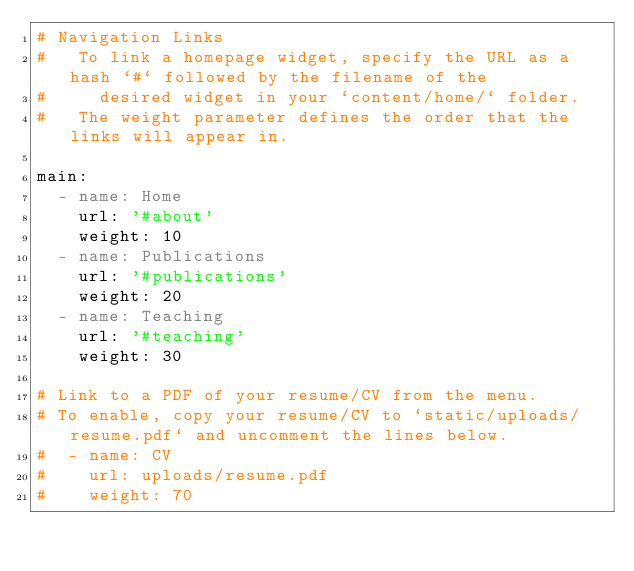<code> <loc_0><loc_0><loc_500><loc_500><_YAML_># Navigation Links
#   To link a homepage widget, specify the URL as a hash `#` followed by the filename of the
#     desired widget in your `content/home/` folder.
#   The weight parameter defines the order that the links will appear in.

main:
  - name: Home
    url: '#about'
    weight: 10
  - name: Publications
    url: '#publications'
    weight: 20
  - name: Teaching
    url: '#teaching'
    weight: 30

# Link to a PDF of your resume/CV from the menu.
# To enable, copy your resume/CV to `static/uploads/resume.pdf` and uncomment the lines below.
#  - name: CV
#    url: uploads/resume.pdf
#    weight: 70
</code> 